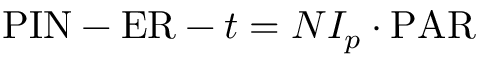<formula> <loc_0><loc_0><loc_500><loc_500>{ P I N } - { E R } - t = N I _ { p } \cdot { P A R }</formula> 